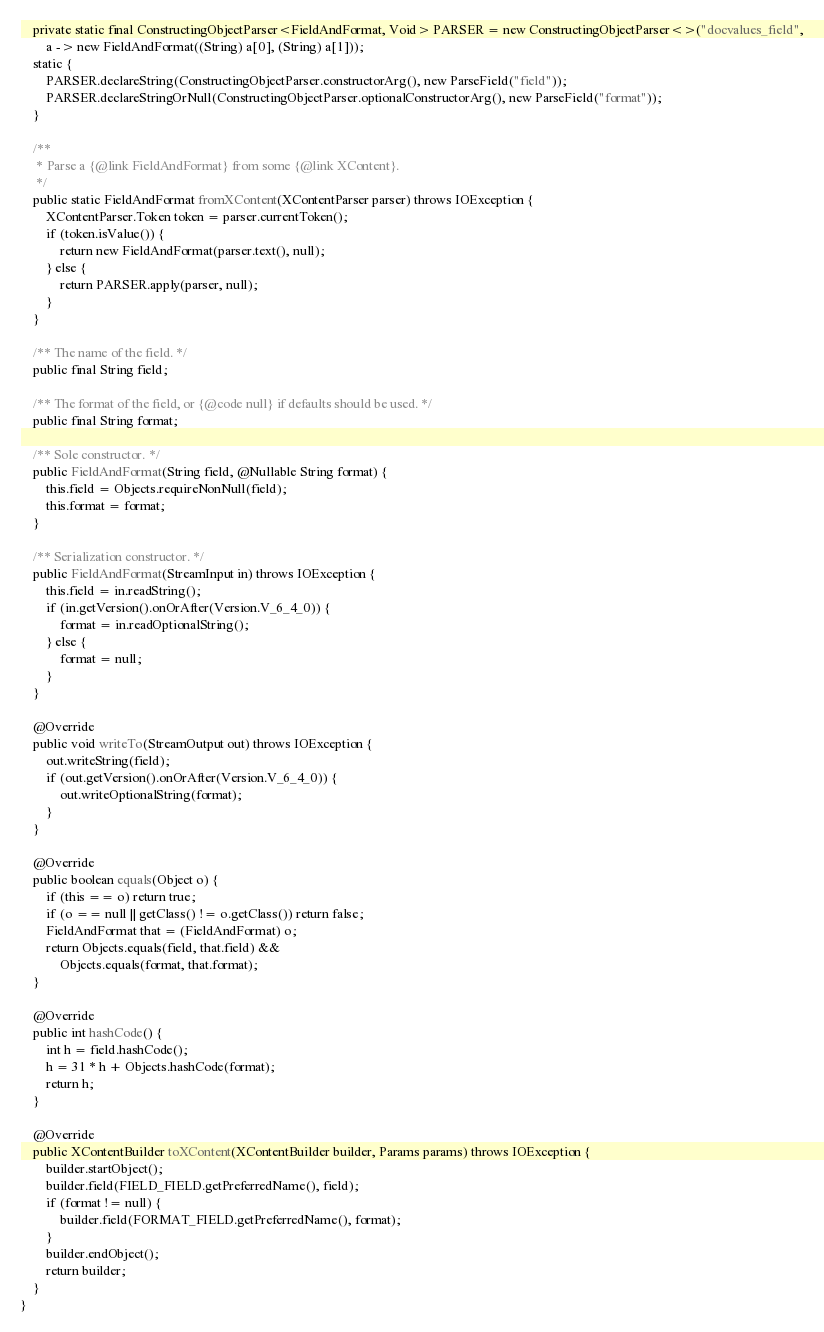Convert code to text. <code><loc_0><loc_0><loc_500><loc_500><_Java_>

    private static final ConstructingObjectParser<FieldAndFormat, Void> PARSER = new ConstructingObjectParser<>("docvalues_field",
        a -> new FieldAndFormat((String) a[0], (String) a[1]));
    static {
        PARSER.declareString(ConstructingObjectParser.constructorArg(), new ParseField("field"));
        PARSER.declareStringOrNull(ConstructingObjectParser.optionalConstructorArg(), new ParseField("format"));
    }

    /**
     * Parse a {@link FieldAndFormat} from some {@link XContent}.
     */
    public static FieldAndFormat fromXContent(XContentParser parser) throws IOException {
        XContentParser.Token token = parser.currentToken();
        if (token.isValue()) {
            return new FieldAndFormat(parser.text(), null);
        } else {
            return PARSER.apply(parser, null);
        }
    }

    /** The name of the field. */
    public final String field;

    /** The format of the field, or {@code null} if defaults should be used. */
    public final String format;

    /** Sole constructor. */
    public FieldAndFormat(String field, @Nullable String format) {
        this.field = Objects.requireNonNull(field);
        this.format = format;
    }

    /** Serialization constructor. */
    public FieldAndFormat(StreamInput in) throws IOException {
        this.field = in.readString();
        if (in.getVersion().onOrAfter(Version.V_6_4_0)) {
            format = in.readOptionalString();
        } else {
            format = null;
        }
    }

    @Override
    public void writeTo(StreamOutput out) throws IOException {
        out.writeString(field);
        if (out.getVersion().onOrAfter(Version.V_6_4_0)) {
            out.writeOptionalString(format);
        }
    }

    @Override
    public boolean equals(Object o) {
        if (this == o) return true;
        if (o == null || getClass() != o.getClass()) return false;
        FieldAndFormat that = (FieldAndFormat) o;
        return Objects.equals(field, that.field) &&
            Objects.equals(format, that.format);
    }

    @Override
    public int hashCode() {
        int h = field.hashCode();
        h = 31 * h + Objects.hashCode(format);
        return h;
    }

    @Override
    public XContentBuilder toXContent(XContentBuilder builder, Params params) throws IOException {
        builder.startObject();
        builder.field(FIELD_FIELD.getPreferredName(), field);
        if (format != null) {
            builder.field(FORMAT_FIELD.getPreferredName(), format);
        }
        builder.endObject();
        return builder;
    }
}
</code> 